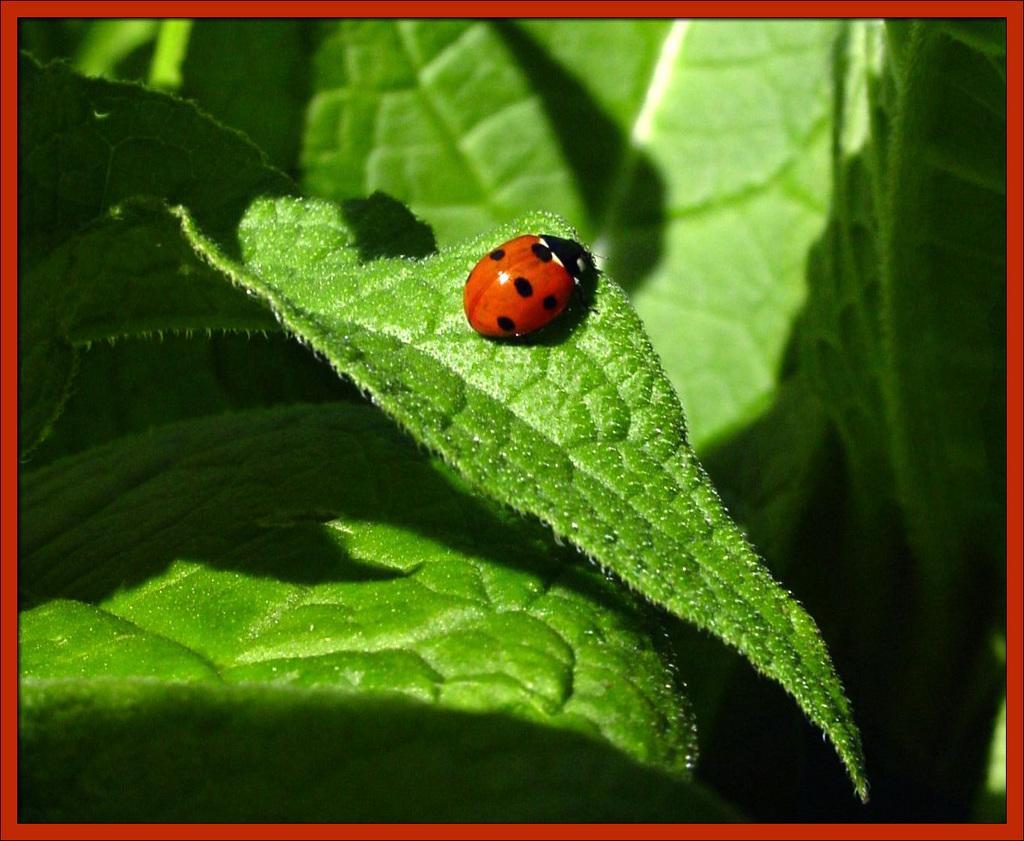Could you give a brief overview of what you see in this image? In the foreground of this image, there is an insect on the leaf around which there are leaves. 